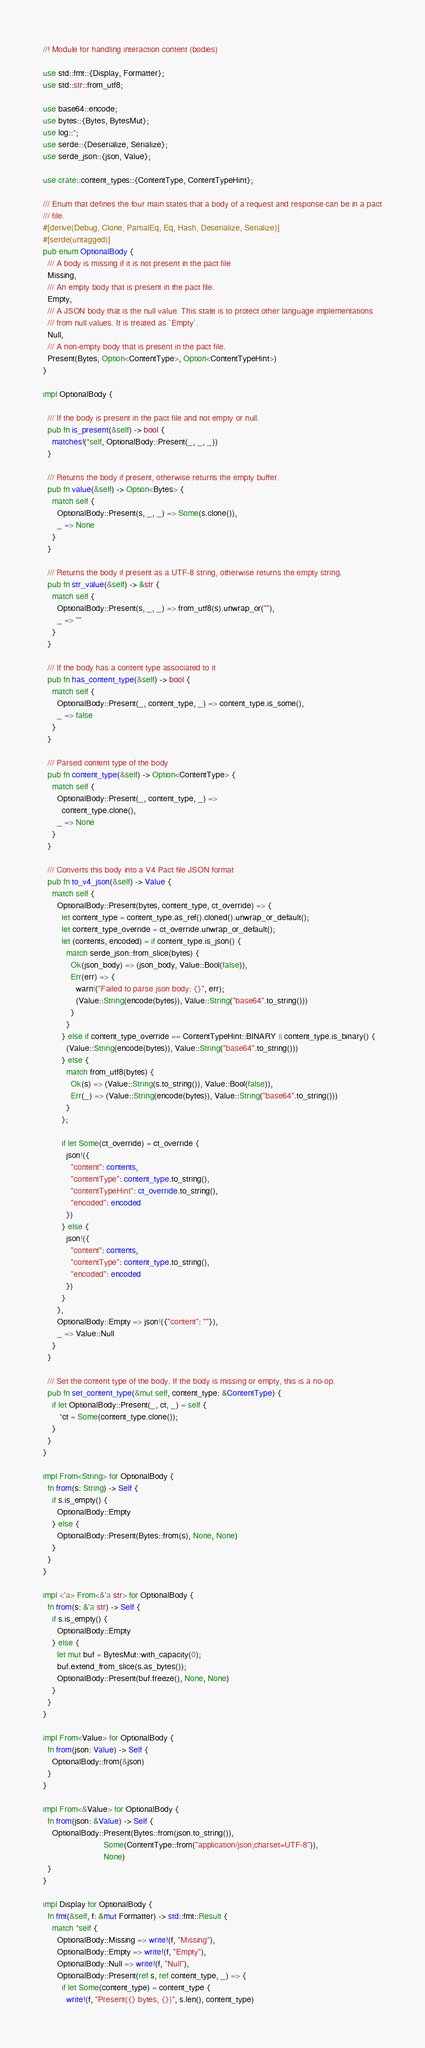Convert code to text. <code><loc_0><loc_0><loc_500><loc_500><_Rust_>//! Module for handling interaction content (bodies)

use std::fmt::{Display, Formatter};
use std::str::from_utf8;

use base64::encode;
use bytes::{Bytes, BytesMut};
use log::*;
use serde::{Deserialize, Serialize};
use serde_json::{json, Value};

use crate::content_types::{ContentType, ContentTypeHint};

/// Enum that defines the four main states that a body of a request and response can be in a pact
/// file.
#[derive(Debug, Clone, PartialEq, Eq, Hash, Deserialize, Serialize)]
#[serde(untagged)]
pub enum OptionalBody {
  /// A body is missing if it is not present in the pact file
  Missing,
  /// An empty body that is present in the pact file.
  Empty,
  /// A JSON body that is the null value. This state is to protect other language implementations
  /// from null values. It is treated as `Empty`.
  Null,
  /// A non-empty body that is present in the pact file.
  Present(Bytes, Option<ContentType>, Option<ContentTypeHint>)
}

impl OptionalBody {

  /// If the body is present in the pact file and not empty or null.
  pub fn is_present(&self) -> bool {
    matches!(*self, OptionalBody::Present(_, _, _))
  }

  /// Returns the body if present, otherwise returns the empty buffer.
  pub fn value(&self) -> Option<Bytes> {
    match self {
      OptionalBody::Present(s, _, _) => Some(s.clone()),
      _ => None
    }
  }

  /// Returns the body if present as a UTF-8 string, otherwise returns the empty string.
  pub fn str_value(&self) -> &str {
    match self {
      OptionalBody::Present(s, _, _) => from_utf8(s).unwrap_or(""),
      _ => ""
    }
  }

  /// If the body has a content type associated to it
  pub fn has_content_type(&self) -> bool {
    match self {
      OptionalBody::Present(_, content_type, _) => content_type.is_some(),
      _ => false
    }
  }

  /// Parsed content type of the body
  pub fn content_type(&self) -> Option<ContentType> {
    match self {
      OptionalBody::Present(_, content_type, _) =>
        content_type.clone(),
      _ => None
    }
  }

  /// Converts this body into a V4 Pact file JSON format
  pub fn to_v4_json(&self) -> Value {
    match self {
      OptionalBody::Present(bytes, content_type, ct_override) => {
        let content_type = content_type.as_ref().cloned().unwrap_or_default();
        let content_type_override = ct_override.unwrap_or_default();
        let (contents, encoded) = if content_type.is_json() {
          match serde_json::from_slice(bytes) {
            Ok(json_body) => (json_body, Value::Bool(false)),
            Err(err) => {
              warn!("Failed to parse json body: {}", err);
              (Value::String(encode(bytes)), Value::String("base64".to_string()))
            }
          }
        } else if content_type_override == ContentTypeHint::BINARY || content_type.is_binary() {
          (Value::String(encode(bytes)), Value::String("base64".to_string()))
        } else {
          match from_utf8(bytes) {
            Ok(s) => (Value::String(s.to_string()), Value::Bool(false)),
            Err(_) => (Value::String(encode(bytes)), Value::String("base64".to_string()))
          }
        };

        if let Some(ct_override) = ct_override {
          json!({
            "content": contents,
            "contentType": content_type.to_string(),
            "contentTypeHint": ct_override.to_string(),
            "encoded": encoded
          })
        } else {
          json!({
            "content": contents,
            "contentType": content_type.to_string(),
            "encoded": encoded
          })
        }
      },
      OptionalBody::Empty => json!({"content": ""}),
      _ => Value::Null
    }
  }

  /// Set the content type of the body. If the body is missing or empty, this is a no-op.
  pub fn set_content_type(&mut self, content_type: &ContentType) {
    if let OptionalBody::Present(_, ct, _) = self {
       *ct = Some(content_type.clone());
    }
  }
}

impl From<String> for OptionalBody {
  fn from(s: String) -> Self {
    if s.is_empty() {
      OptionalBody::Empty
    } else {
      OptionalBody::Present(Bytes::from(s), None, None)
    }
  }
}

impl <'a> From<&'a str> for OptionalBody {
  fn from(s: &'a str) -> Self {
    if s.is_empty() {
      OptionalBody::Empty
    } else {
      let mut buf = BytesMut::with_capacity(0);
      buf.extend_from_slice(s.as_bytes());
      OptionalBody::Present(buf.freeze(), None, None)
    }
  }
}

impl From<Value> for OptionalBody {
  fn from(json: Value) -> Self {
    OptionalBody::from(&json)
  }
}

impl From<&Value> for OptionalBody {
  fn from(json: &Value) -> Self {
    OptionalBody::Present(Bytes::from(json.to_string()),
                          Some(ContentType::from("application/json;charset=UTF-8")),
                          None)
  }
}

impl Display for OptionalBody {
  fn fmt(&self, f: &mut Formatter) -> std::fmt::Result {
    match *self {
      OptionalBody::Missing => write!(f, "Missing"),
      OptionalBody::Empty => write!(f, "Empty"),
      OptionalBody::Null => write!(f, "Null"),
      OptionalBody::Present(ref s, ref content_type, _) => {
        if let Some(content_type) = content_type {
          write!(f, "Present({} bytes, {})", s.len(), content_type)</code> 